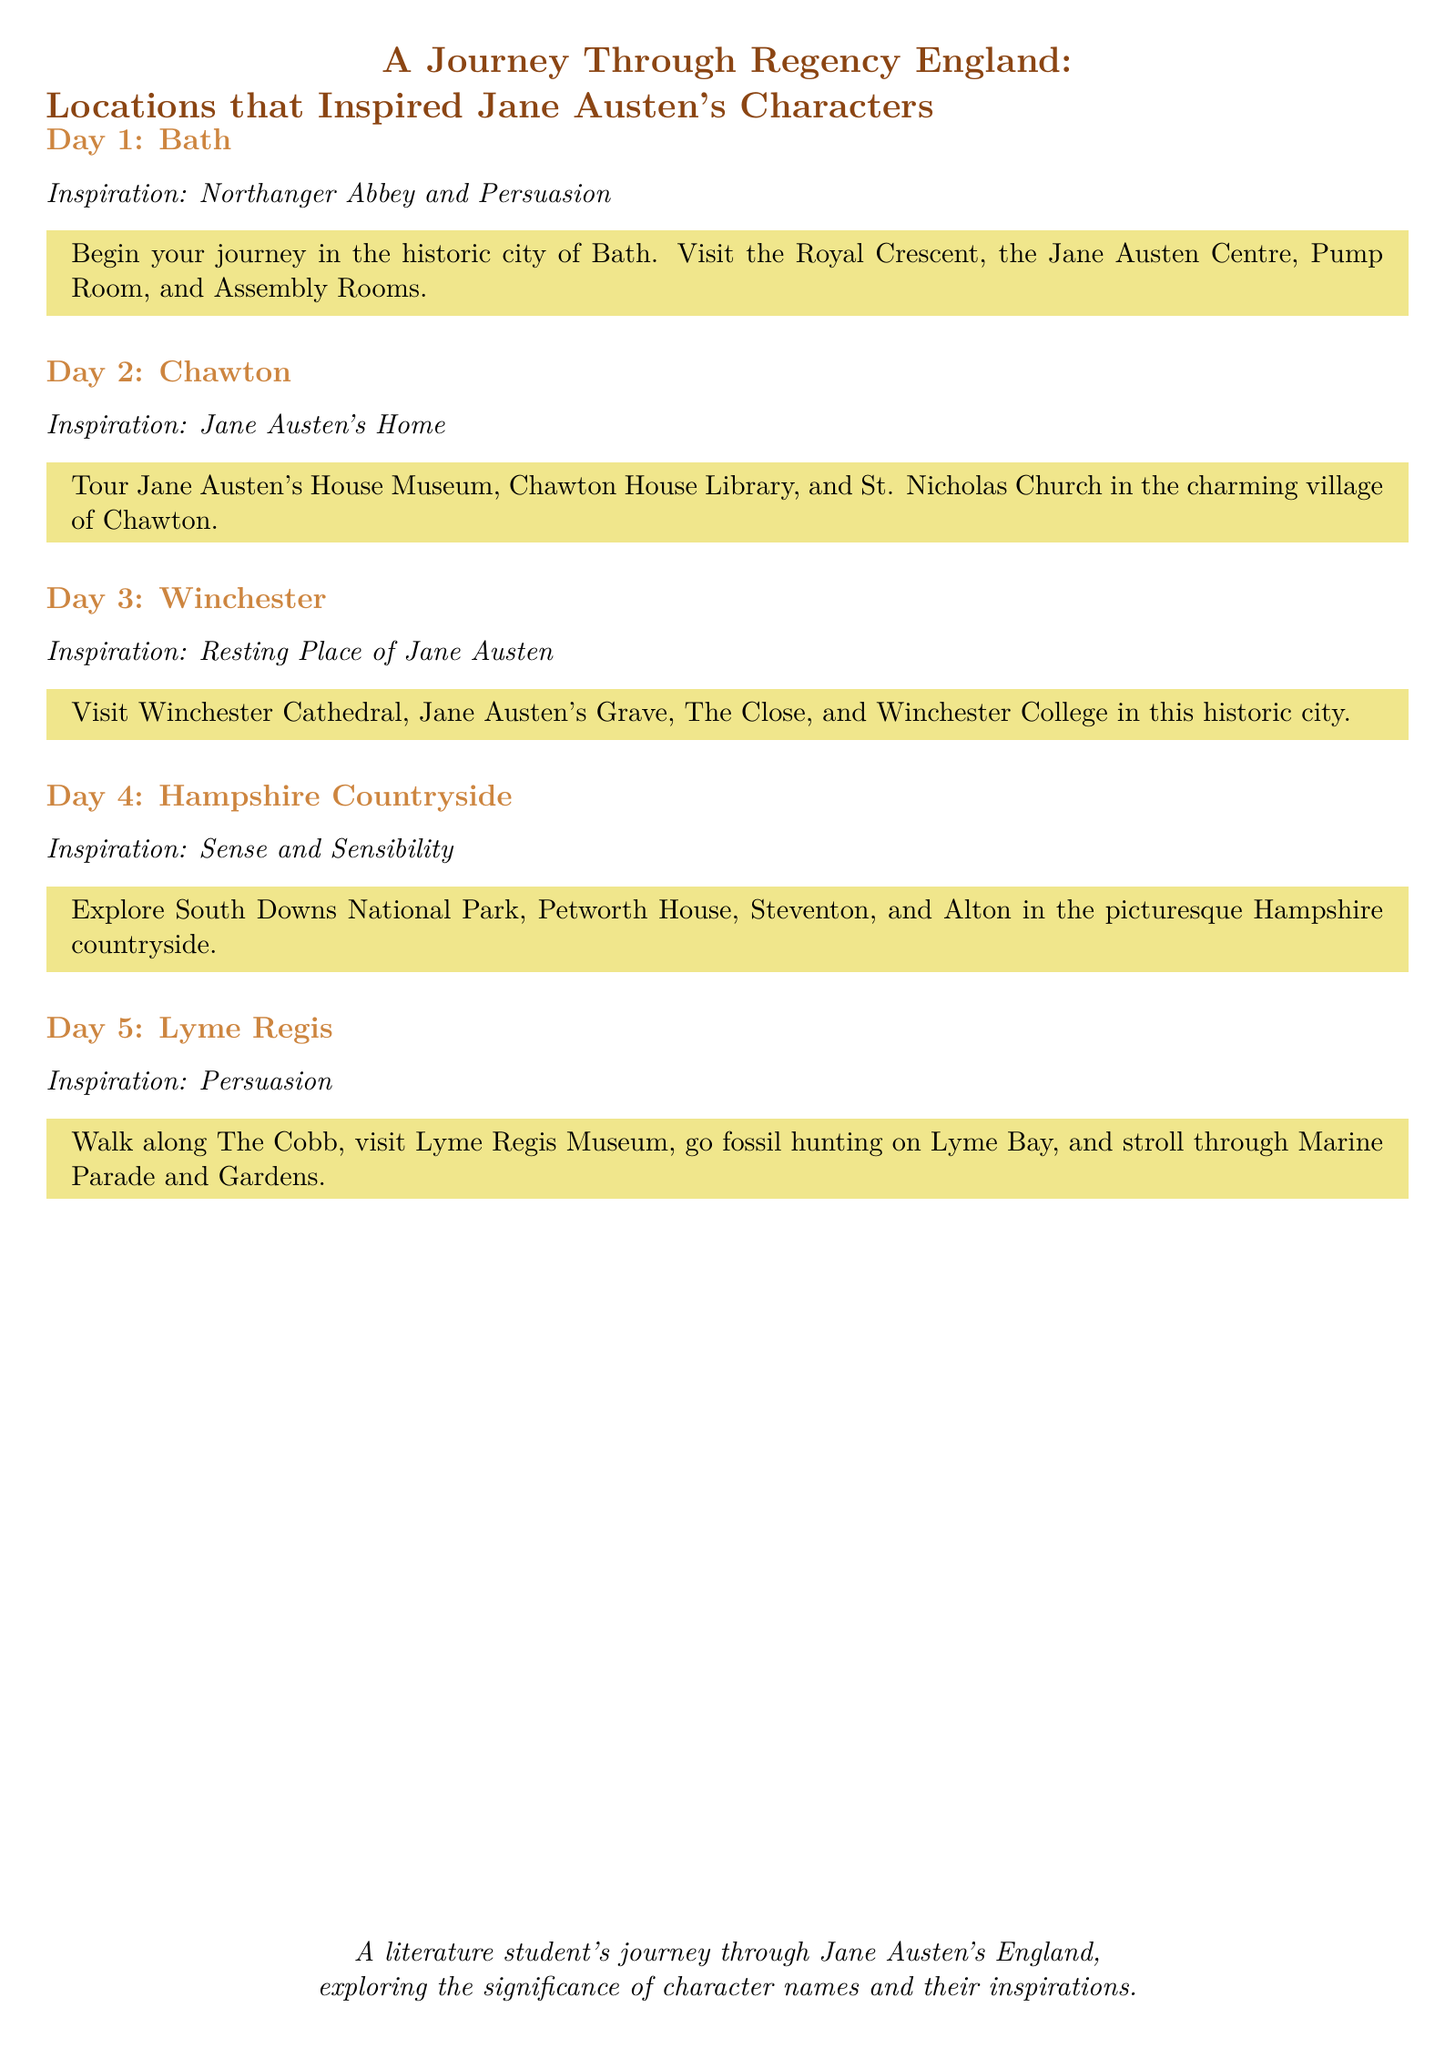What city is the starting point of the journey? The document mentions Bath as the first location to visit on the journey through Regency England.
Answer: Bath Which Jane Austen novels are linked to Bath? The document connects Bath with two novels: Northanger Abbey and Persuasion.
Answer: Northanger Abbey and Persuasion What is the focus of Day 2 itinerary? Day 2 focuses on visiting Jane Austen's home and related locations such as her house museum.
Answer: Jane Austen's Home Which site is highlighted for Day 3? The document specifies Winchester Cathedral as a significant site for Day 3 in the itinerary.
Answer: Winchester Cathedral What is the key theme of Day 4? The focus of Day 4 centers on exploring the Hampshire countryside, especially its connection to Sense and Sensibility.
Answer: Sense and Sensibility What type of activity is suggested for Day 5? For Day 5, activities include walking along The Cobb and fossil hunting, reflecting the coastal attraction of Lyme Regis.
Answer: Walk along The Cobb What type of character connections does the journey emphasize? The document emphasizes the significance of character names and their inspirations in Jane Austen's works.
Answer: Character names and their inspirations How many days does the itinerary cover? The document details a journey spanning five days through locations related to Jane Austen.
Answer: Five days Where is Jane Austen's grave located? The itinerary indicates that Jane Austen's grave is situated in Winchester Cathedral.
Answer: Winchester Cathedral 